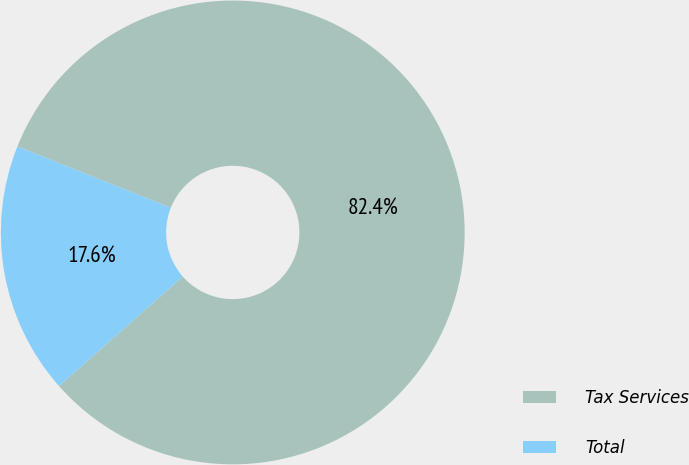Convert chart to OTSL. <chart><loc_0><loc_0><loc_500><loc_500><pie_chart><fcel>Tax Services<fcel>Total<nl><fcel>82.43%<fcel>17.57%<nl></chart> 